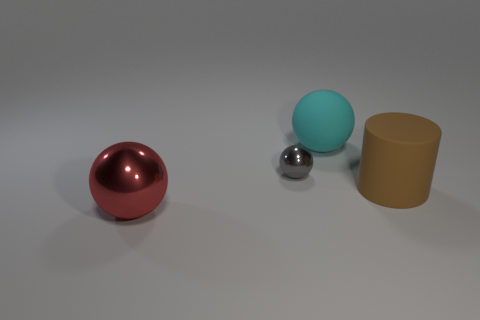Subtract all matte spheres. How many spheres are left? 2 Add 3 blue rubber objects. How many objects exist? 7 Subtract all red balls. How many balls are left? 2 Subtract 3 balls. How many balls are left? 0 Subtract all cylinders. How many objects are left? 3 Subtract all purple cubes. How many red spheres are left? 1 Add 2 big cylinders. How many big cylinders are left? 3 Add 3 gray things. How many gray things exist? 4 Subtract 1 brown cylinders. How many objects are left? 3 Subtract all gray cylinders. Subtract all blue spheres. How many cylinders are left? 1 